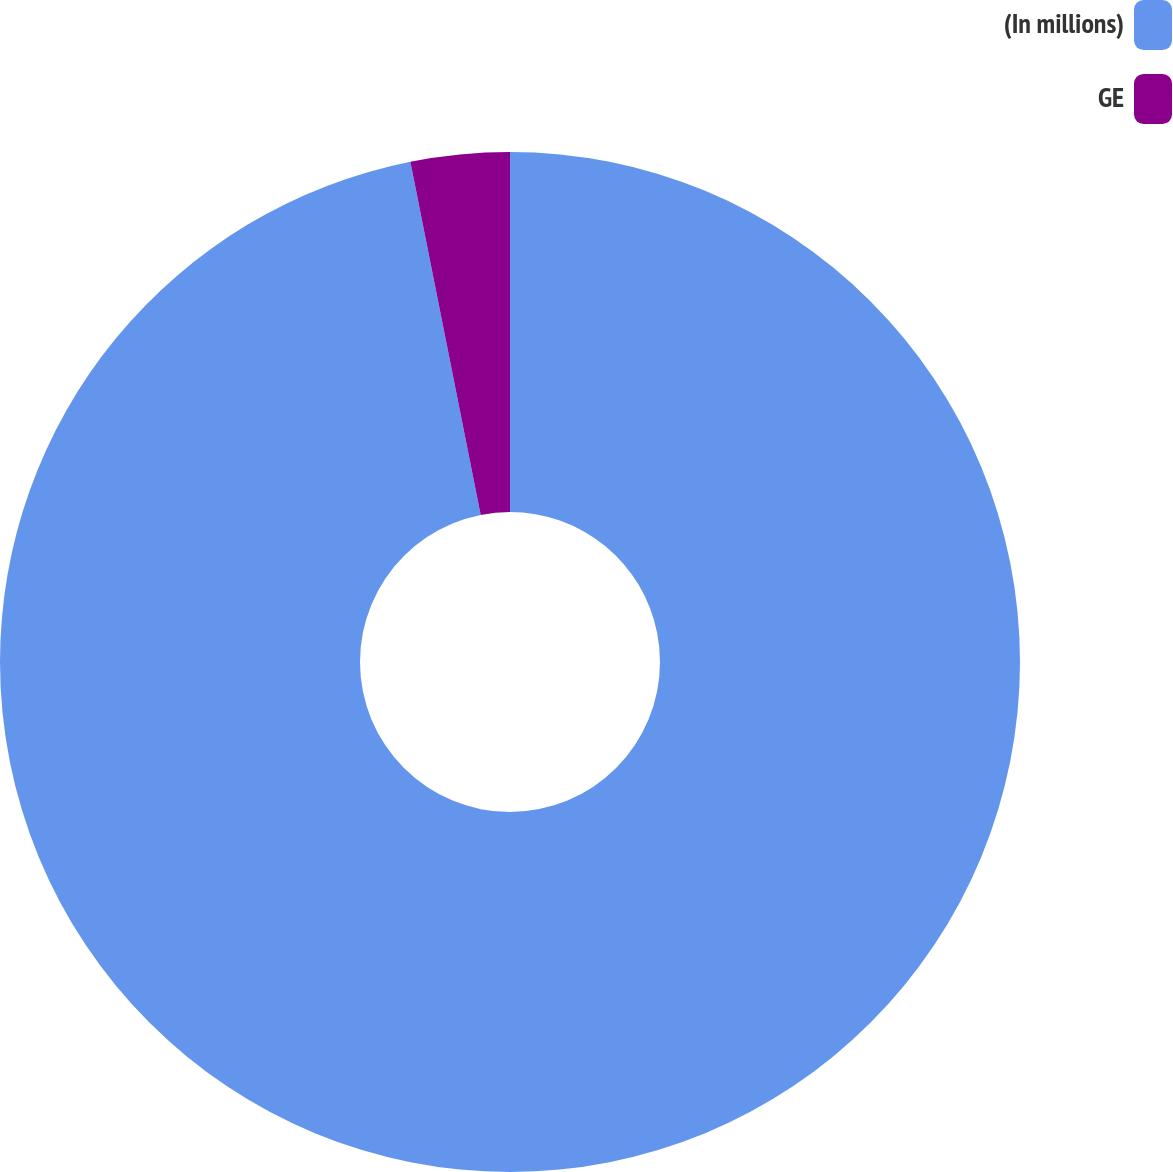<chart> <loc_0><loc_0><loc_500><loc_500><pie_chart><fcel>(In millions)<fcel>GE<nl><fcel>96.87%<fcel>3.13%<nl></chart> 